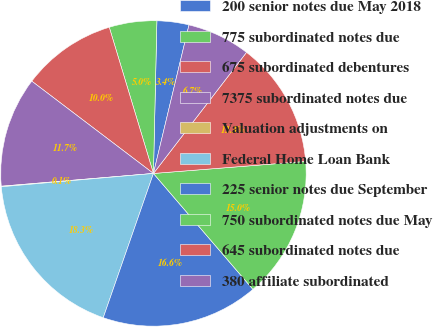Convert chart to OTSL. <chart><loc_0><loc_0><loc_500><loc_500><pie_chart><fcel>200 senior notes due May 2018<fcel>775 subordinated notes due<fcel>675 subordinated debentures<fcel>7375 subordinated notes due<fcel>Valuation adjustments on<fcel>Federal Home Loan Bank<fcel>225 senior notes due September<fcel>750 subordinated notes due May<fcel>645 subordinated notes due<fcel>380 affiliate subordinated<nl><fcel>3.38%<fcel>5.03%<fcel>10.0%<fcel>11.66%<fcel>0.06%<fcel>18.28%<fcel>16.62%<fcel>14.97%<fcel>13.31%<fcel>6.69%<nl></chart> 